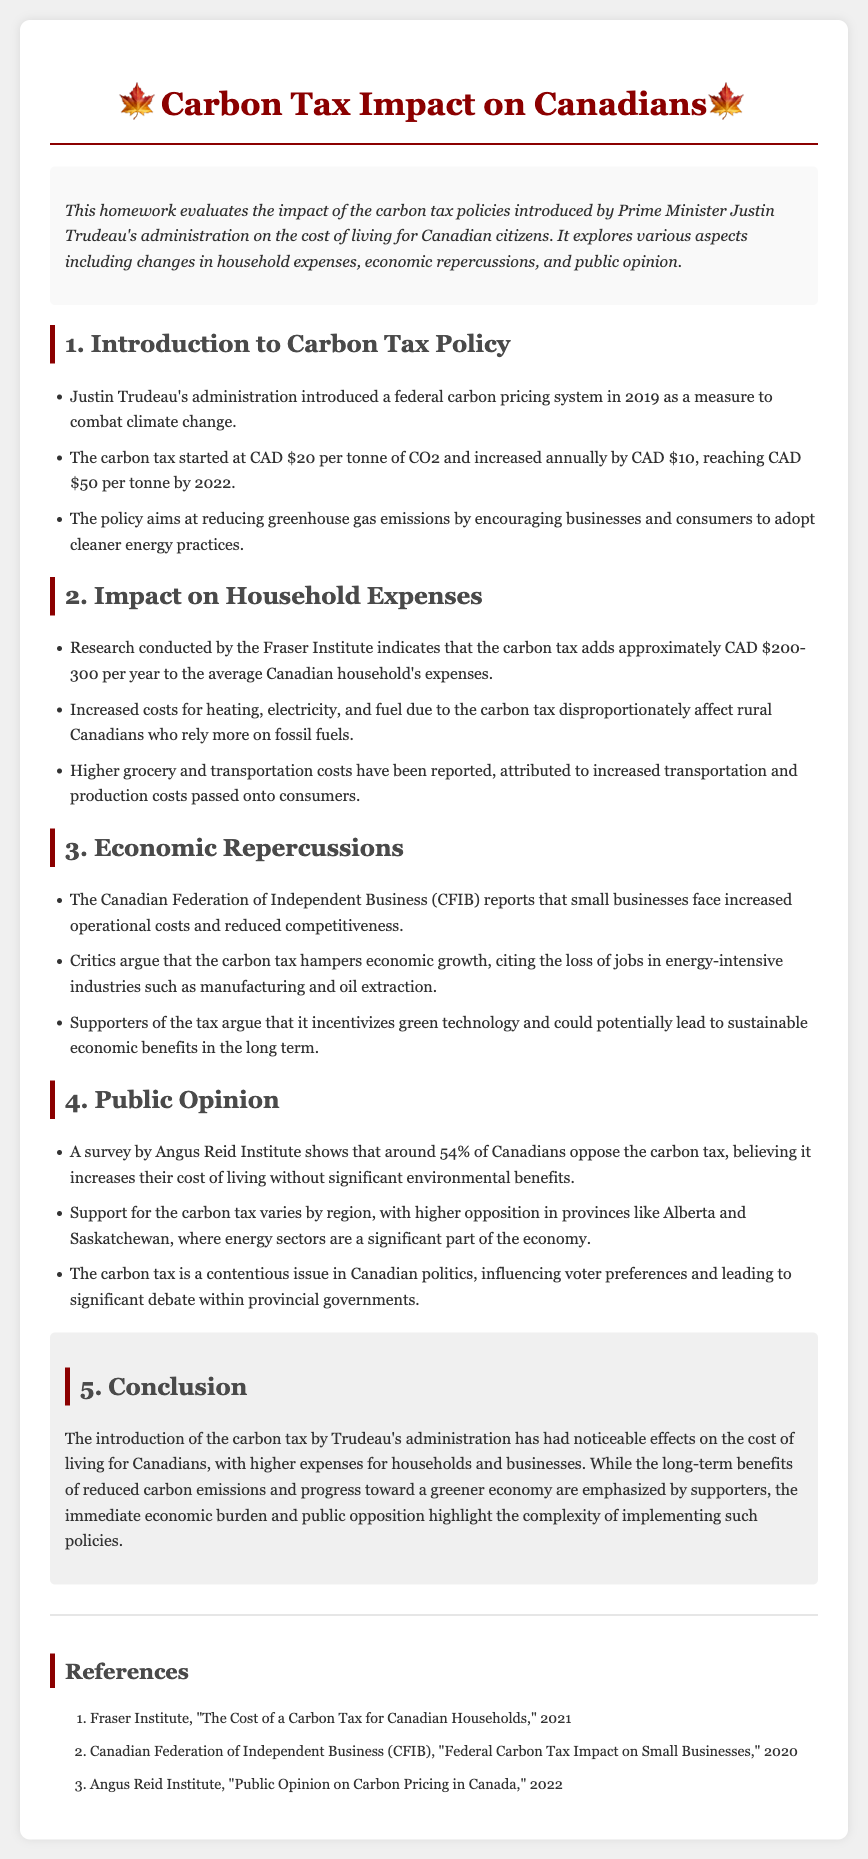What year was the federal carbon pricing system introduced? The document states that the federal carbon pricing system was introduced in 2019.
Answer: 2019 What is the initial price per tonne of CO2 when the carbon tax started? The carbon tax started at CAD $20 per tonne of CO2.
Answer: CAD $20 How much additional cost does the carbon tax add to the average Canadian household's expenses per year? The document mentions that the carbon tax adds approximately CAD $200-300 per year to the average household's expenses.
Answer: CAD $200-300 What percentage of Canadians oppose the carbon tax according to the Angus Reid Institute survey? The survey shows that around 54% of Canadians oppose the carbon tax.
Answer: 54% Which provinces show higher opposition to the carbon tax? The document indicates that there is higher opposition to the carbon tax in provinces like Alberta and Saskatchewan.
Answer: Alberta and Saskatchewan What is one argument made by critics regarding the carbon tax? Critics argue that the carbon tax hampers economic growth.
Answer: hampers economic growth How much does the carbon tax increase annually after it started? The carbon tax increases annually by CAD $10.
Answer: CAD $10 What is a possible long-term benefit mentioned by supporters of the carbon tax? Supporters argue that it incentivizes green technology.
Answer: incentivizes green technology 